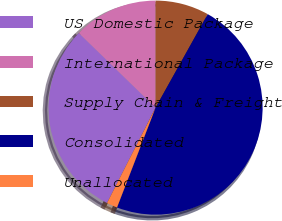<chart> <loc_0><loc_0><loc_500><loc_500><pie_chart><fcel>US Domestic Package<fcel>International Package<fcel>Supply Chain & Freight<fcel>Consolidated<fcel>Unallocated<nl><fcel>29.79%<fcel>12.72%<fcel>8.1%<fcel>47.77%<fcel>1.62%<nl></chart> 